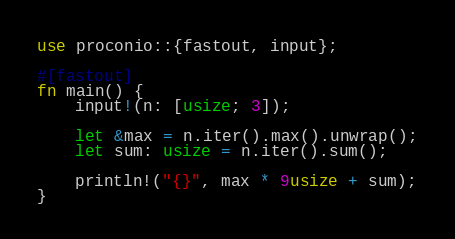Convert code to text. <code><loc_0><loc_0><loc_500><loc_500><_Rust_>use proconio::{fastout, input};

#[fastout]
fn main() {
    input!(n: [usize; 3]);

    let &max = n.iter().max().unwrap();
    let sum: usize = n.iter().sum();

    println!("{}", max * 9usize + sum);
}
</code> 